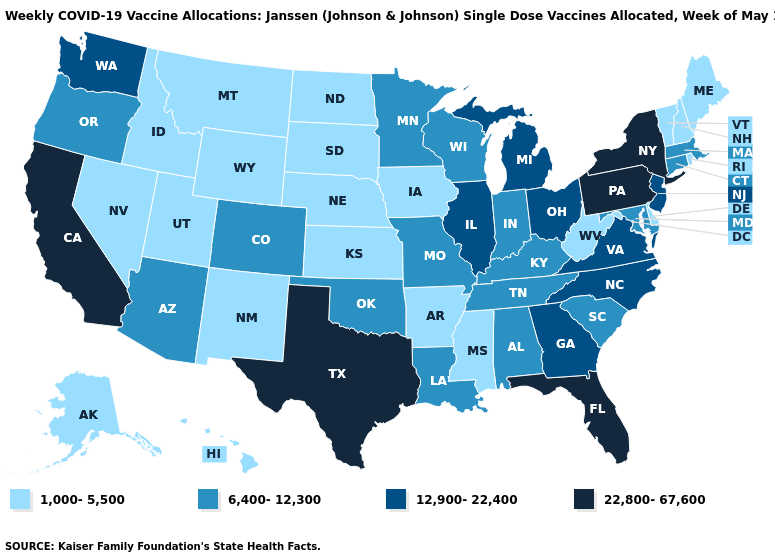Among the states that border Pennsylvania , which have the lowest value?
Concise answer only. Delaware, West Virginia. Which states hav the highest value in the Northeast?
Be succinct. New York, Pennsylvania. Does Oklahoma have a higher value than Hawaii?
Short answer required. Yes. Name the states that have a value in the range 6,400-12,300?
Answer briefly. Alabama, Arizona, Colorado, Connecticut, Indiana, Kentucky, Louisiana, Maryland, Massachusetts, Minnesota, Missouri, Oklahoma, Oregon, South Carolina, Tennessee, Wisconsin. Name the states that have a value in the range 12,900-22,400?
Keep it brief. Georgia, Illinois, Michigan, New Jersey, North Carolina, Ohio, Virginia, Washington. What is the lowest value in the South?
Write a very short answer. 1,000-5,500. What is the value of Utah?
Concise answer only. 1,000-5,500. Which states have the highest value in the USA?
Write a very short answer. California, Florida, New York, Pennsylvania, Texas. What is the value of Louisiana?
Write a very short answer. 6,400-12,300. What is the highest value in the MidWest ?
Be succinct. 12,900-22,400. Which states hav the highest value in the West?
Keep it brief. California. Among the states that border Connecticut , which have the highest value?
Write a very short answer. New York. Name the states that have a value in the range 1,000-5,500?
Keep it brief. Alaska, Arkansas, Delaware, Hawaii, Idaho, Iowa, Kansas, Maine, Mississippi, Montana, Nebraska, Nevada, New Hampshire, New Mexico, North Dakota, Rhode Island, South Dakota, Utah, Vermont, West Virginia, Wyoming. Does New Hampshire have the highest value in the USA?
Be succinct. No. Which states have the highest value in the USA?
Give a very brief answer. California, Florida, New York, Pennsylvania, Texas. 